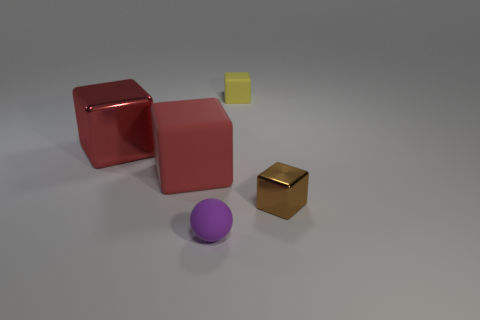There is a tiny block in front of the shiny object that is to the left of the small yellow rubber thing; what color is it?
Offer a very short reply. Brown. There is another object that is the same color as the large shiny thing; what is its material?
Offer a terse response. Rubber. There is a shiny block that is behind the brown cube; what color is it?
Make the answer very short. Red. There is a metal object that is to the right of the red rubber block; is its size the same as the yellow block?
Your answer should be compact. Yes. The shiny cube that is the same color as the large rubber thing is what size?
Offer a terse response. Large. Are there any rubber cylinders of the same size as the sphere?
Your answer should be compact. No. There is a small thing to the left of the small yellow object; does it have the same color as the tiny cube that is in front of the yellow rubber thing?
Make the answer very short. No. Are there any other rubber spheres of the same color as the tiny sphere?
Keep it short and to the point. No. What number of other objects are there of the same shape as the brown metallic object?
Make the answer very short. 3. What shape is the small matte object in front of the yellow rubber block?
Ensure brevity in your answer.  Sphere. 